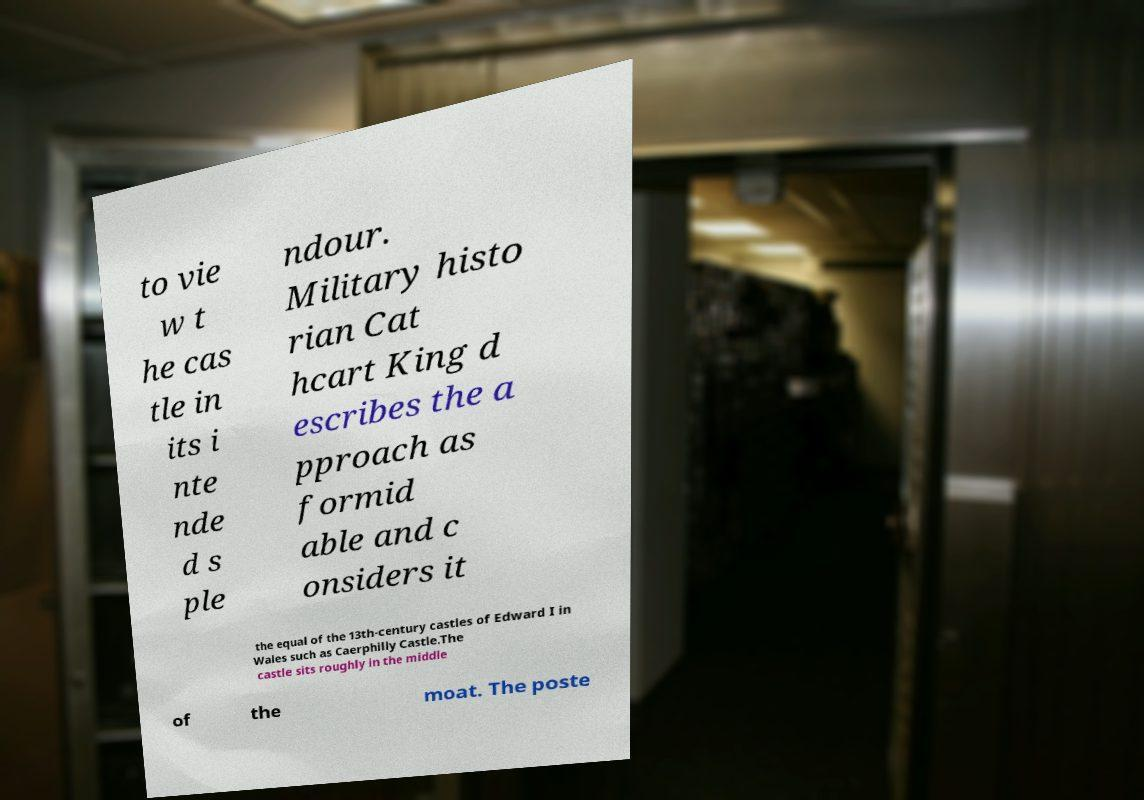What messages or text are displayed in this image? I need them in a readable, typed format. to vie w t he cas tle in its i nte nde d s ple ndour. Military histo rian Cat hcart King d escribes the a pproach as formid able and c onsiders it the equal of the 13th-century castles of Edward I in Wales such as Caerphilly Castle.The castle sits roughly in the middle of the moat. The poste 